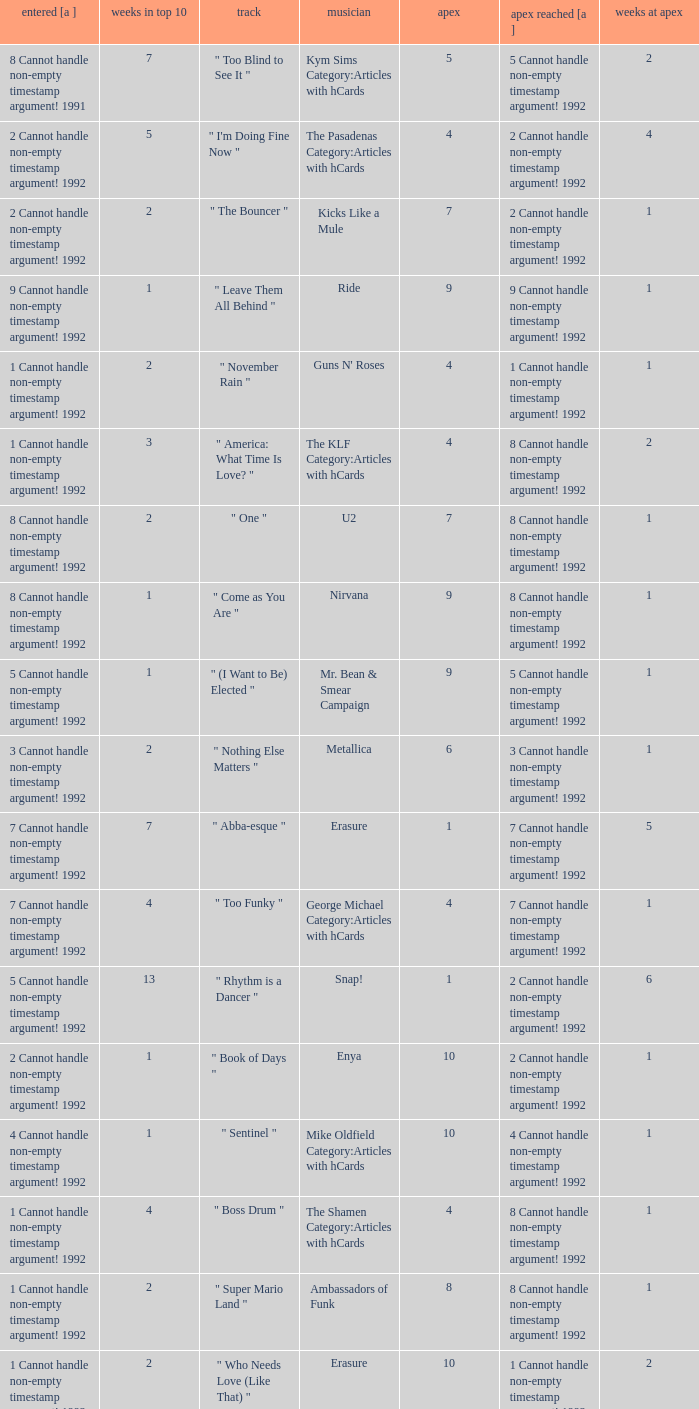What was the peak reached for a single with 4 weeks in the top 10 and entered in 7 cannot handle non-empty timestamp argument! 1992? 7 Cannot handle non-empty timestamp argument! 1992. 